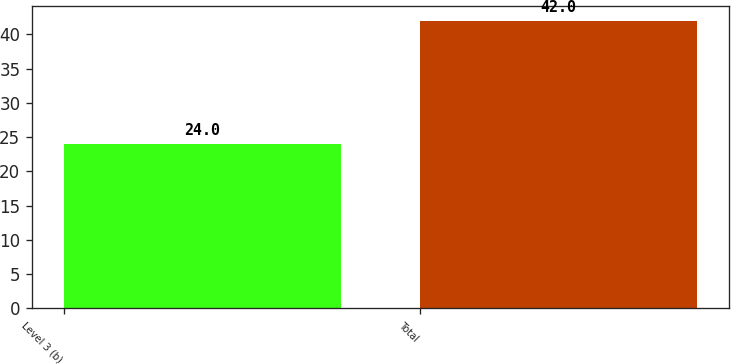Convert chart. <chart><loc_0><loc_0><loc_500><loc_500><bar_chart><fcel>Level 3 (b)<fcel>Total<nl><fcel>24<fcel>42<nl></chart> 